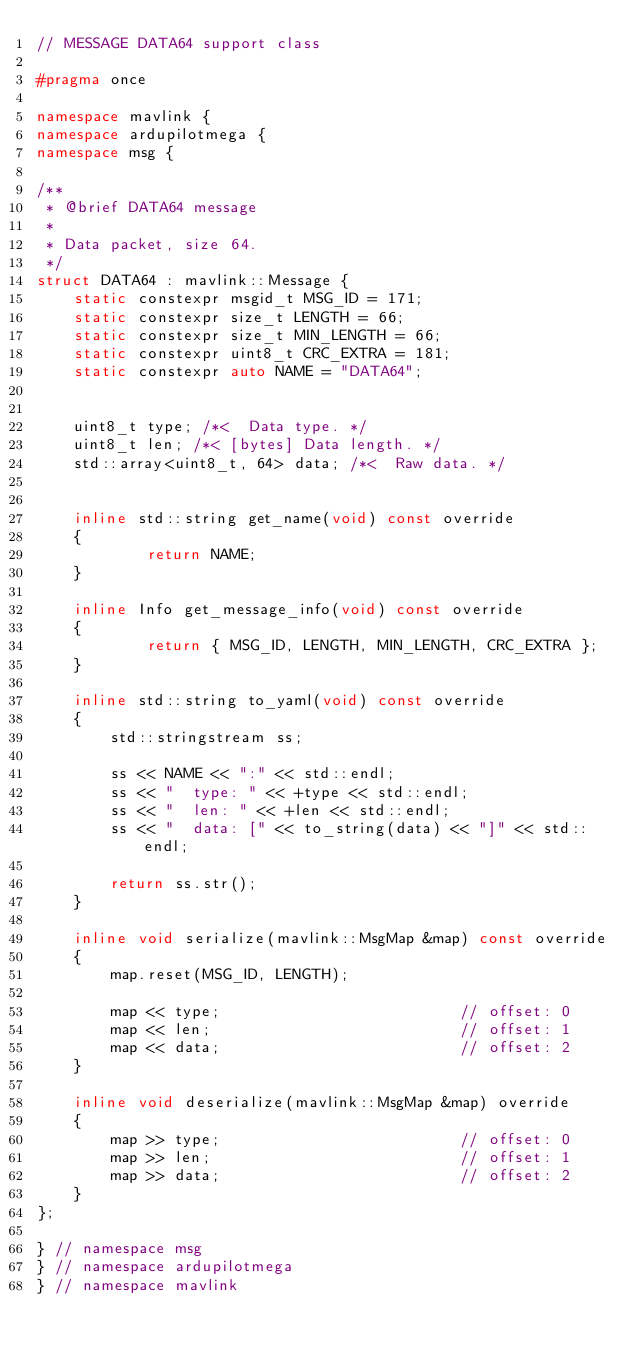Convert code to text. <code><loc_0><loc_0><loc_500><loc_500><_C++_>// MESSAGE DATA64 support class

#pragma once

namespace mavlink {
namespace ardupilotmega {
namespace msg {

/**
 * @brief DATA64 message
 *
 * Data packet, size 64.
 */
struct DATA64 : mavlink::Message {
    static constexpr msgid_t MSG_ID = 171;
    static constexpr size_t LENGTH = 66;
    static constexpr size_t MIN_LENGTH = 66;
    static constexpr uint8_t CRC_EXTRA = 181;
    static constexpr auto NAME = "DATA64";


    uint8_t type; /*<  Data type. */
    uint8_t len; /*< [bytes] Data length. */
    std::array<uint8_t, 64> data; /*<  Raw data. */


    inline std::string get_name(void) const override
    {
            return NAME;
    }

    inline Info get_message_info(void) const override
    {
            return { MSG_ID, LENGTH, MIN_LENGTH, CRC_EXTRA };
    }

    inline std::string to_yaml(void) const override
    {
        std::stringstream ss;

        ss << NAME << ":" << std::endl;
        ss << "  type: " << +type << std::endl;
        ss << "  len: " << +len << std::endl;
        ss << "  data: [" << to_string(data) << "]" << std::endl;

        return ss.str();
    }

    inline void serialize(mavlink::MsgMap &map) const override
    {
        map.reset(MSG_ID, LENGTH);

        map << type;                          // offset: 0
        map << len;                           // offset: 1
        map << data;                          // offset: 2
    }

    inline void deserialize(mavlink::MsgMap &map) override
    {
        map >> type;                          // offset: 0
        map >> len;                           // offset: 1
        map >> data;                          // offset: 2
    }
};

} // namespace msg
} // namespace ardupilotmega
} // namespace mavlink
</code> 